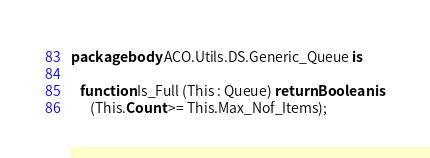<code> <loc_0><loc_0><loc_500><loc_500><_Ada_>package body ACO.Utils.DS.Generic_Queue is

   function Is_Full (This : Queue) return Boolean is
      (This.Count >= This.Max_Nof_Items);
</code> 